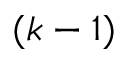Convert formula to latex. <formula><loc_0><loc_0><loc_500><loc_500>( k - 1 )</formula> 